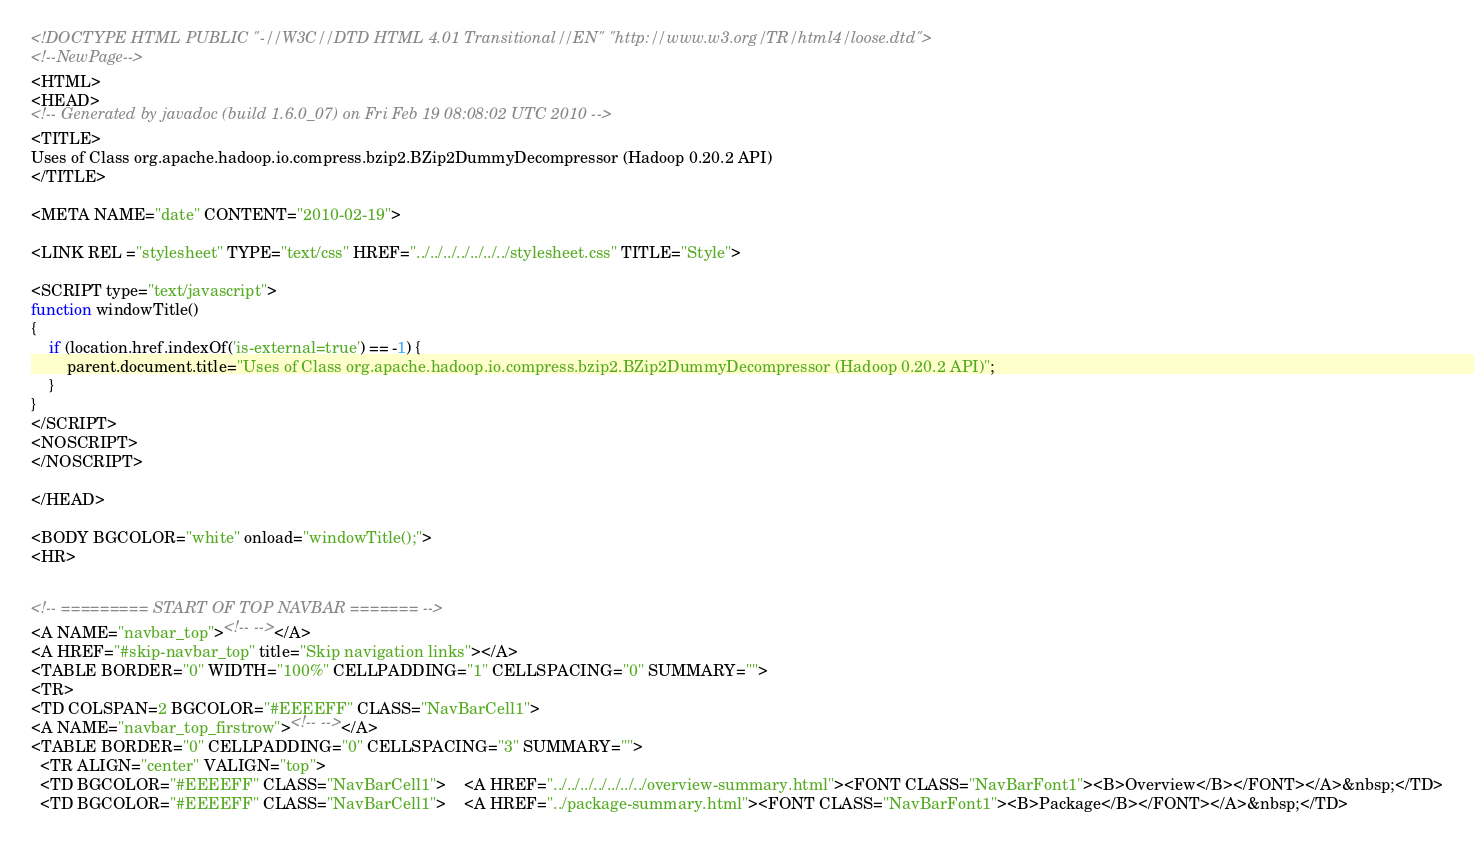Convert code to text. <code><loc_0><loc_0><loc_500><loc_500><_HTML_><!DOCTYPE HTML PUBLIC "-//W3C//DTD HTML 4.01 Transitional//EN" "http://www.w3.org/TR/html4/loose.dtd">
<!--NewPage-->
<HTML>
<HEAD>
<!-- Generated by javadoc (build 1.6.0_07) on Fri Feb 19 08:08:02 UTC 2010 -->
<TITLE>
Uses of Class org.apache.hadoop.io.compress.bzip2.BZip2DummyDecompressor (Hadoop 0.20.2 API)
</TITLE>

<META NAME="date" CONTENT="2010-02-19">

<LINK REL ="stylesheet" TYPE="text/css" HREF="../../../../../../../stylesheet.css" TITLE="Style">

<SCRIPT type="text/javascript">
function windowTitle()
{
    if (location.href.indexOf('is-external=true') == -1) {
        parent.document.title="Uses of Class org.apache.hadoop.io.compress.bzip2.BZip2DummyDecompressor (Hadoop 0.20.2 API)";
    }
}
</SCRIPT>
<NOSCRIPT>
</NOSCRIPT>

</HEAD>

<BODY BGCOLOR="white" onload="windowTitle();">
<HR>


<!-- ========= START OF TOP NAVBAR ======= -->
<A NAME="navbar_top"><!-- --></A>
<A HREF="#skip-navbar_top" title="Skip navigation links"></A>
<TABLE BORDER="0" WIDTH="100%" CELLPADDING="1" CELLSPACING="0" SUMMARY="">
<TR>
<TD COLSPAN=2 BGCOLOR="#EEEEFF" CLASS="NavBarCell1">
<A NAME="navbar_top_firstrow"><!-- --></A>
<TABLE BORDER="0" CELLPADDING="0" CELLSPACING="3" SUMMARY="">
  <TR ALIGN="center" VALIGN="top">
  <TD BGCOLOR="#EEEEFF" CLASS="NavBarCell1">    <A HREF="../../../../../../../overview-summary.html"><FONT CLASS="NavBarFont1"><B>Overview</B></FONT></A>&nbsp;</TD>
  <TD BGCOLOR="#EEEEFF" CLASS="NavBarCell1">    <A HREF="../package-summary.html"><FONT CLASS="NavBarFont1"><B>Package</B></FONT></A>&nbsp;</TD></code> 